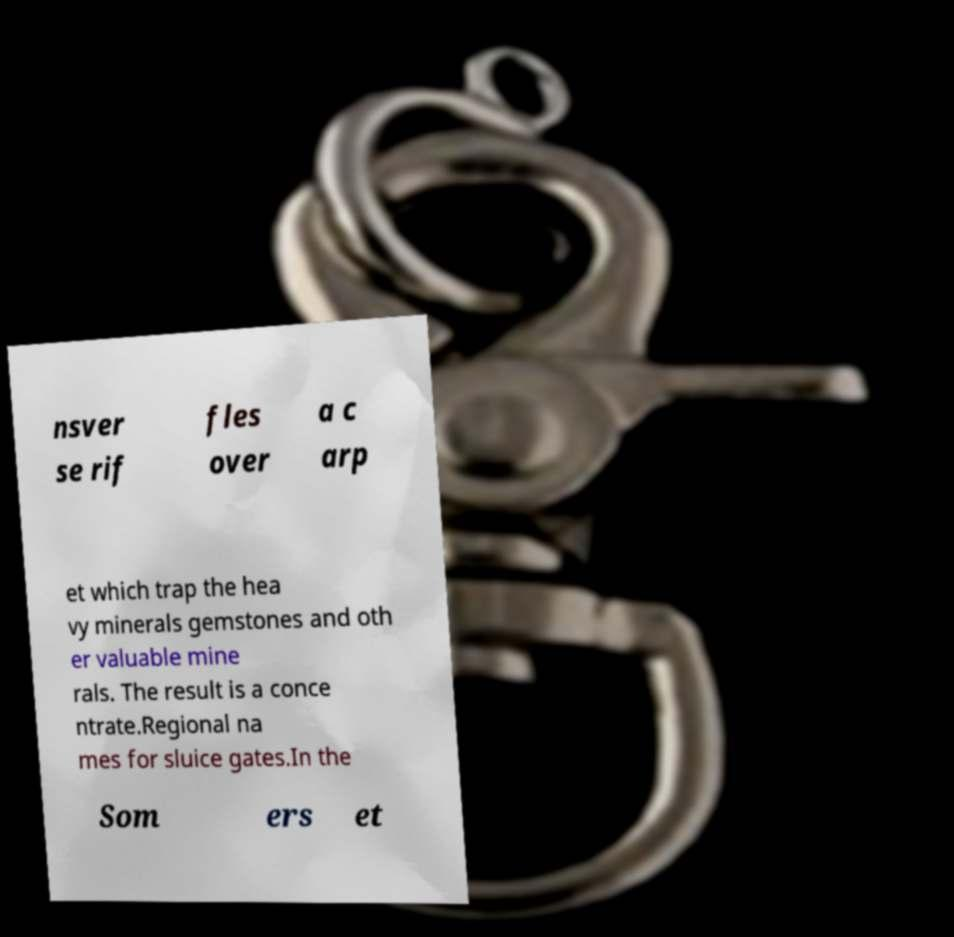Could you assist in decoding the text presented in this image and type it out clearly? nsver se rif fles over a c arp et which trap the hea vy minerals gemstones and oth er valuable mine rals. The result is a conce ntrate.Regional na mes for sluice gates.In the Som ers et 